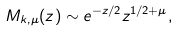<formula> <loc_0><loc_0><loc_500><loc_500>M _ { k , \mu } ( z ) \sim e ^ { - z / 2 } z ^ { 1 / 2 + \mu } ,</formula> 